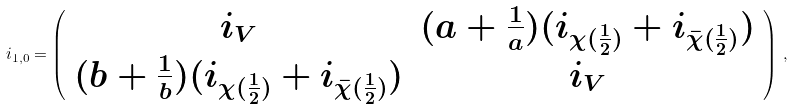Convert formula to latex. <formula><loc_0><loc_0><loc_500><loc_500>i _ { 1 , 0 } = \left ( \begin{array} { c c } i _ { V } & ( a + \frac { 1 } { a } ) ( i _ { \chi ( \frac { 1 } { 2 } ) } + i _ { \bar { \chi } ( \frac { 1 } { 2 } ) } ) \\ ( b + \frac { 1 } { b } ) ( i _ { \chi ( \frac { 1 } { 2 } ) } + i _ { \bar { \chi } ( \frac { 1 } { 2 } ) } ) & i _ { V } \end{array} \right ) \, ,</formula> 